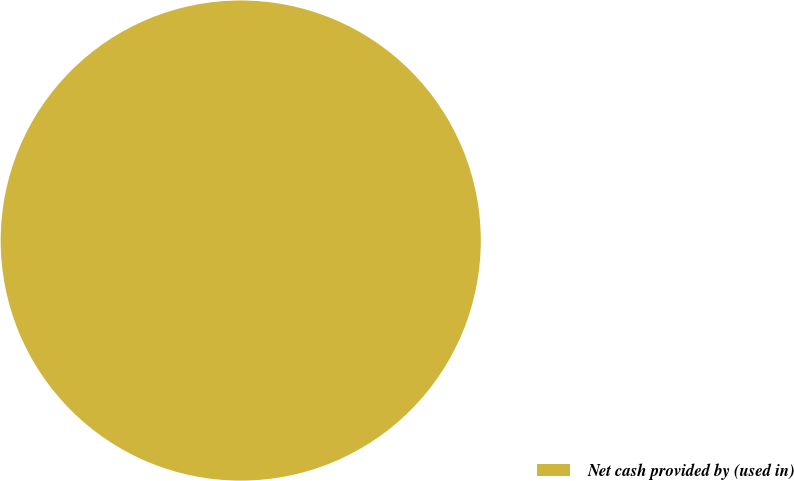<chart> <loc_0><loc_0><loc_500><loc_500><pie_chart><fcel>Net cash provided by (used in)<nl><fcel>100.0%<nl></chart> 